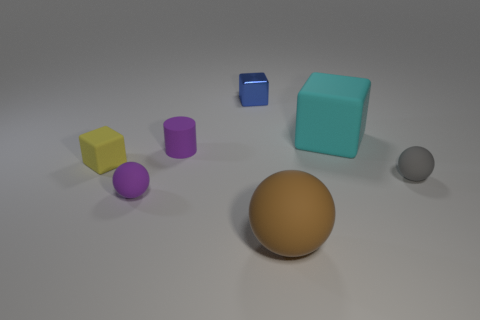Subtract all small balls. How many balls are left? 1 Subtract all purple balls. How many balls are left? 2 Subtract all balls. How many objects are left? 4 Subtract 1 blocks. How many blocks are left? 2 Add 5 yellow cubes. How many yellow cubes exist? 6 Add 1 brown rubber balls. How many objects exist? 8 Subtract 0 red cylinders. How many objects are left? 7 Subtract all yellow balls. Subtract all blue blocks. How many balls are left? 3 Subtract all blue cubes. How many purple spheres are left? 1 Subtract all big purple matte cylinders. Subtract all tiny purple matte things. How many objects are left? 5 